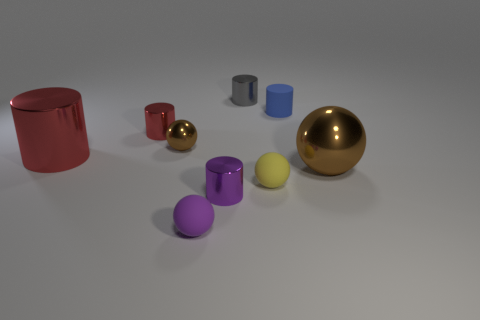The other red object that is the same shape as the small red metallic thing is what size?
Your answer should be compact. Large. There is a purple metallic thing; is it the same size as the object that is right of the small blue cylinder?
Offer a very short reply. No. Are there any small matte spheres behind the brown ball that is in front of the small brown ball?
Provide a short and direct response. No. There is a large object in front of the large cylinder; what is its shape?
Provide a succinct answer. Sphere. There is a tiny cylinder that is in front of the large metal thing to the left of the tiny red metal cylinder; what color is it?
Ensure brevity in your answer.  Purple. There is a large object that is the same shape as the tiny purple matte thing; what is it made of?
Your answer should be very brief. Metal. How many brown metal balls are the same size as the purple matte sphere?
Provide a short and direct response. 1. What color is the big ball that is the same material as the purple cylinder?
Ensure brevity in your answer.  Brown. Is the number of rubber things less than the number of purple matte spheres?
Keep it short and to the point. No. How many gray things are either shiny cylinders or matte objects?
Offer a terse response. 1. 